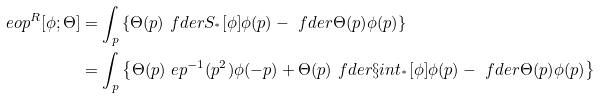<formula> <loc_0><loc_0><loc_500><loc_500>\ e o p ^ { R } [ \phi ; \Theta ] & = \int _ { p } \left \{ \Theta ( p ) \ f d e r { S _ { ^ { * } } [ \phi ] } { \phi ( p ) } - \ f d e r { \Theta ( p ) } { \phi ( p ) } \right \} \\ & = \int _ { p } \left \{ \Theta ( p ) \ e p ^ { - 1 } ( p ^ { 2 } ) \phi ( - p ) + \Theta ( p ) \ f d e r { \S i n t _ { ^ { * } } [ \phi ] } { \phi ( p ) } - \ f d e r { \Theta ( p ) } { \phi ( p ) } \right \}</formula> 